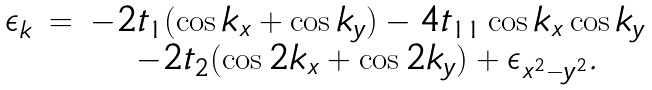Convert formula to latex. <formula><loc_0><loc_0><loc_500><loc_500>\begin{array} { c c c } \epsilon _ { k } & = & - 2 t _ { 1 } ( \cos k _ { x } + \cos k _ { y } ) - 4 t _ { 1 1 } \cos k _ { x } \cos k _ { y } \\ & & - 2 t _ { 2 } ( \cos 2 k _ { x } + \cos 2 k _ { y } ) + \epsilon _ { x ^ { 2 } - y ^ { 2 } } . \\ \end{array}</formula> 